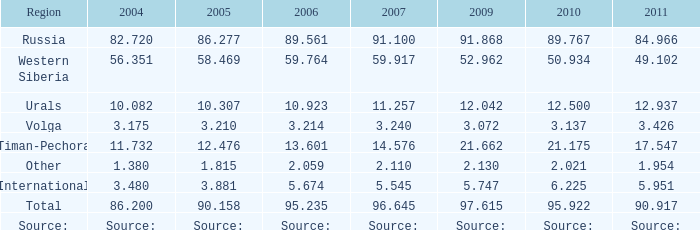What is the 2005 Lukoil oil prodroduction when in 2007 oil production 91.100 million tonnes? 86.277. 